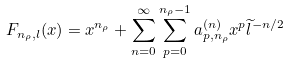<formula> <loc_0><loc_0><loc_500><loc_500>F _ { n _ { \rho } , l } ( x ) = x ^ { n _ { \rho } } + \sum _ { n = 0 } ^ { \infty } \sum _ { p = 0 } ^ { n _ { \rho } - 1 } a _ { p , n _ { \rho } } ^ { ( n ) } x ^ { p } \widetilde { l } ^ { - n / 2 }</formula> 